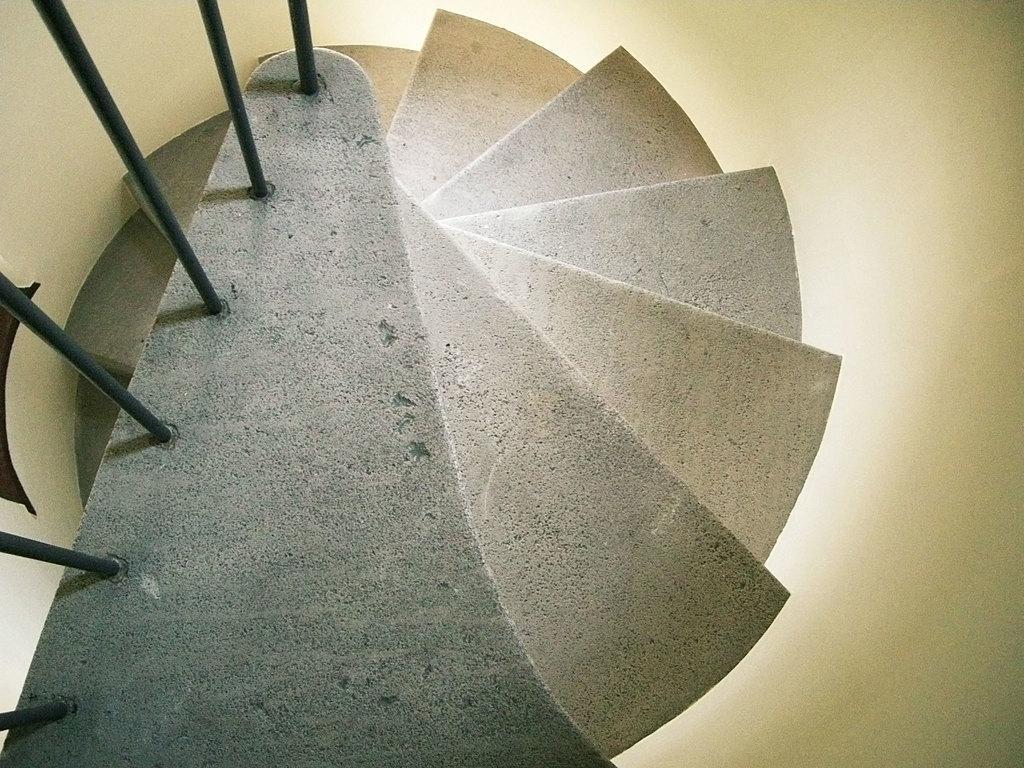Please provide a concise description of this image. In the picture we can see the steps and near it we can see the iron rods to it. 